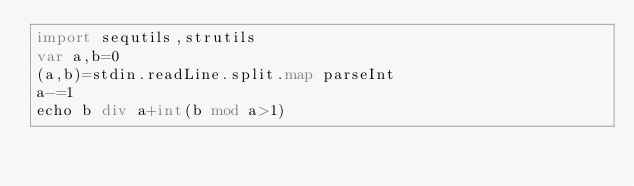Convert code to text. <code><loc_0><loc_0><loc_500><loc_500><_Nim_>import sequtils,strutils
var a,b=0
(a,b)=stdin.readLine.split.map parseInt
a-=1
echo b div a+int(b mod a>1)</code> 